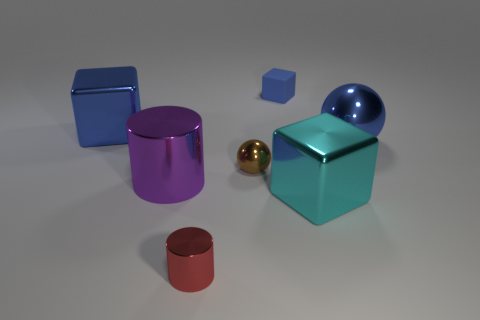What is the small blue object made of?
Provide a short and direct response. Rubber. There is a shiny cylinder behind the cyan metallic thing; how many tiny rubber blocks are in front of it?
Your answer should be compact. 0. There is a big metallic ball; is it the same color as the shiny cube to the left of the small rubber cube?
Offer a very short reply. Yes. There is a ball that is the same size as the purple cylinder; what color is it?
Make the answer very short. Blue. Are there any blue matte things that have the same shape as the large cyan object?
Offer a terse response. Yes. Is the number of brown balls less than the number of purple metallic spheres?
Give a very brief answer. No. What color is the metal cylinder that is left of the red thing?
Make the answer very short. Purple. The big blue thing that is on the right side of the tiny matte block on the left side of the cyan thing is what shape?
Provide a short and direct response. Sphere. Does the small ball have the same material as the blue block that is on the right side of the purple shiny cylinder?
Your answer should be very brief. No. What is the shape of the large metallic object that is the same color as the large ball?
Give a very brief answer. Cube. 